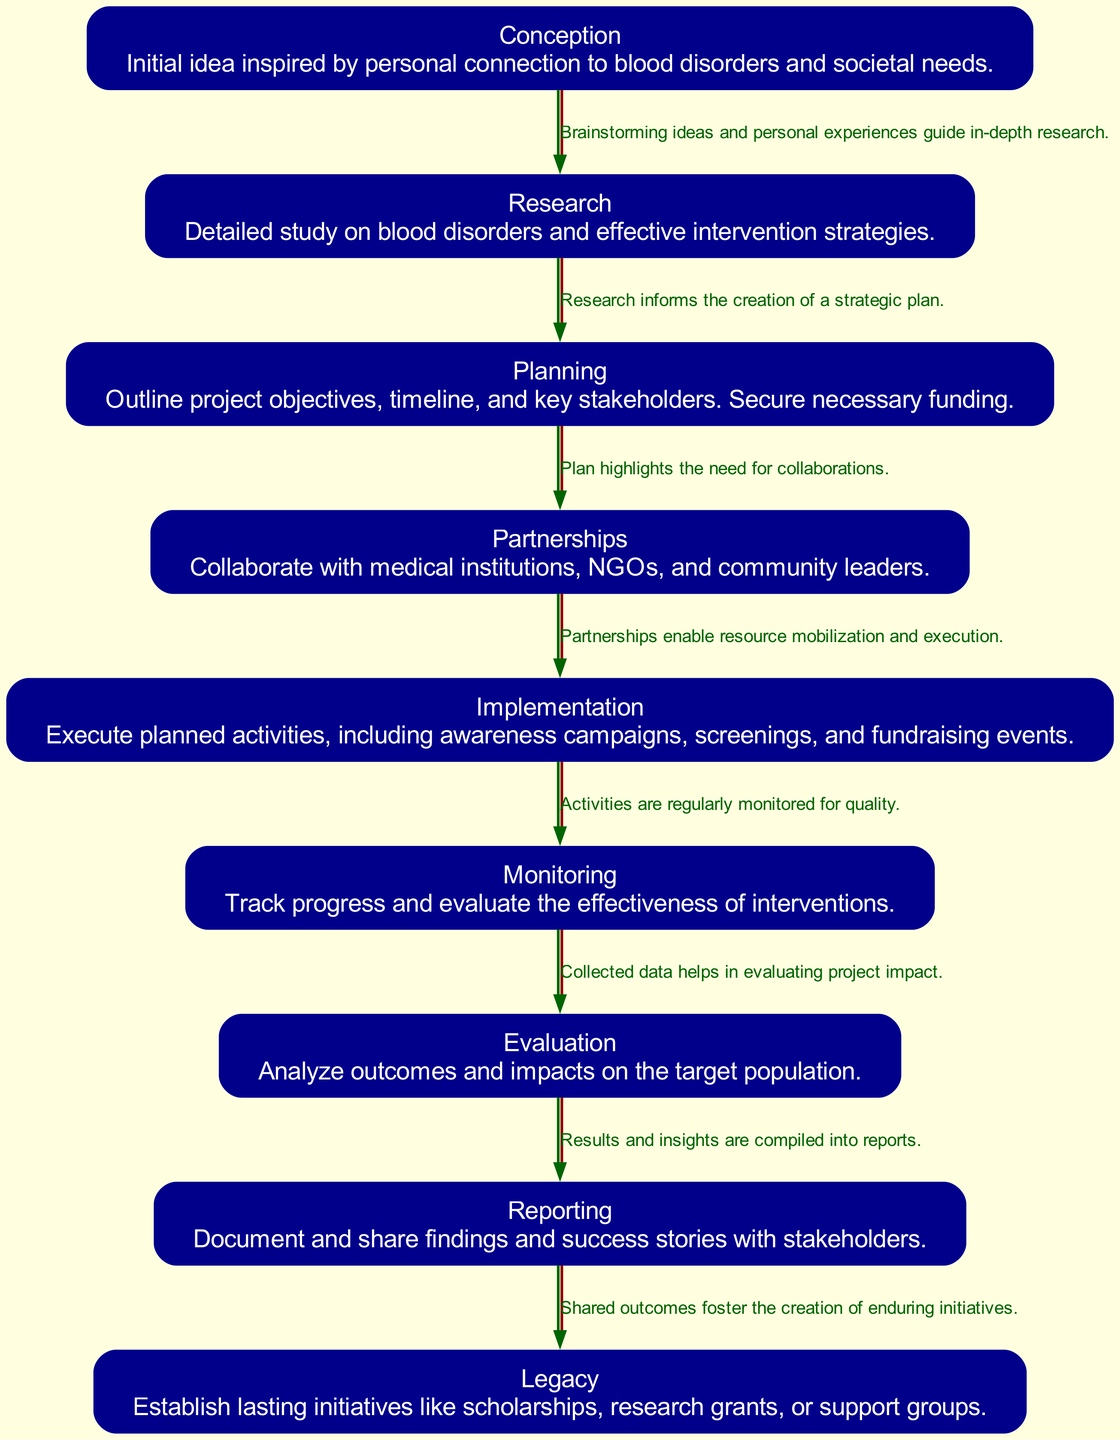What is the first phase of the project lifecycle? The first phase in the diagram is the "Conception" phase, where the initial idea is developed based on personal connections and societal needs.
Answer: Conception How many nodes are present in the diagram? By counting each distinct phase represented as a node in the diagram, there are a total of nine nodes indicating the various stages of a philanthropic project lifecycle.
Answer: 9 What does the "Implementation" phase involve? The "Implementation" phase includes executing planned activities such as awareness campaigns, screenings, and fundraising events, signifying the active execution of the project plan.
Answer: Execute planned activities What connects "Monitoring" to "Evaluation"? The edge labeled "Collected data helps in evaluating project impact" illustrates how monitoring provides the necessary information that leads to the evaluation of the project's effectiveness.
Answer: Collected data Which phase emphasizes collaborations? The "Partnerships" phase focuses on collaboration with medical institutions, NGOs, and community leaders to enhance the project's effectiveness and resource mobilization.
Answer: Partnerships What document arises after the "Evaluation" phase? The "Reporting" phase follows the evaluation, where results and insights from the project are compiled into documents that can be shared with stakeholders.
Answer: Reporting What is a key outcome of the "Reporting" phase? The key outcome of the "Reporting" phase is the creation of enduring initiatives that serve as a lasting legacy, fostering long-term impact from the project.
Answer: Establish lasting initiatives How does "Research" influence "Planning"? The edge labeled "Research informs the creation of a strategic plan" shows that the insights garnered during the research phase are critical for developing an effective project strategy in the planning phase.
Answer: Informs the creation of a strategic plan What is the main focus of the "Legacy" phase? The "Legacy" phase concentrates on establishing ongoing initiatives like scholarships, research grants, or support groups that constitute the lasting impact of the philanthropic project.
Answer: Lasting initiatives 